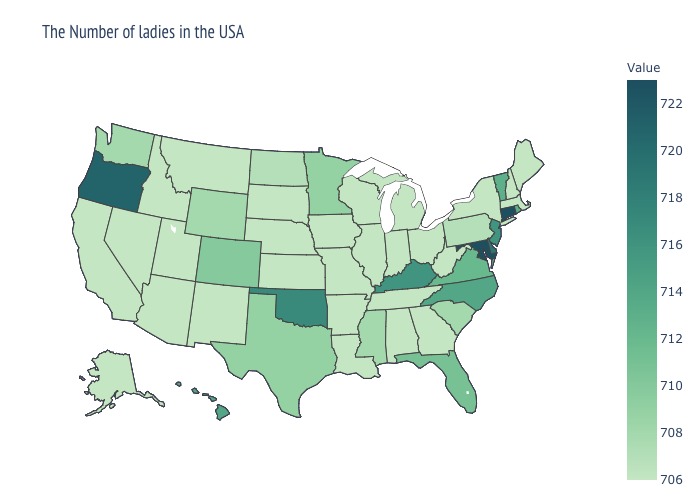Which states have the highest value in the USA?
Quick response, please. Connecticut, Maryland. Does Minnesota have a higher value than Illinois?
Concise answer only. Yes. Among the states that border Michigan , which have the highest value?
Write a very short answer. Ohio, Indiana, Wisconsin. 